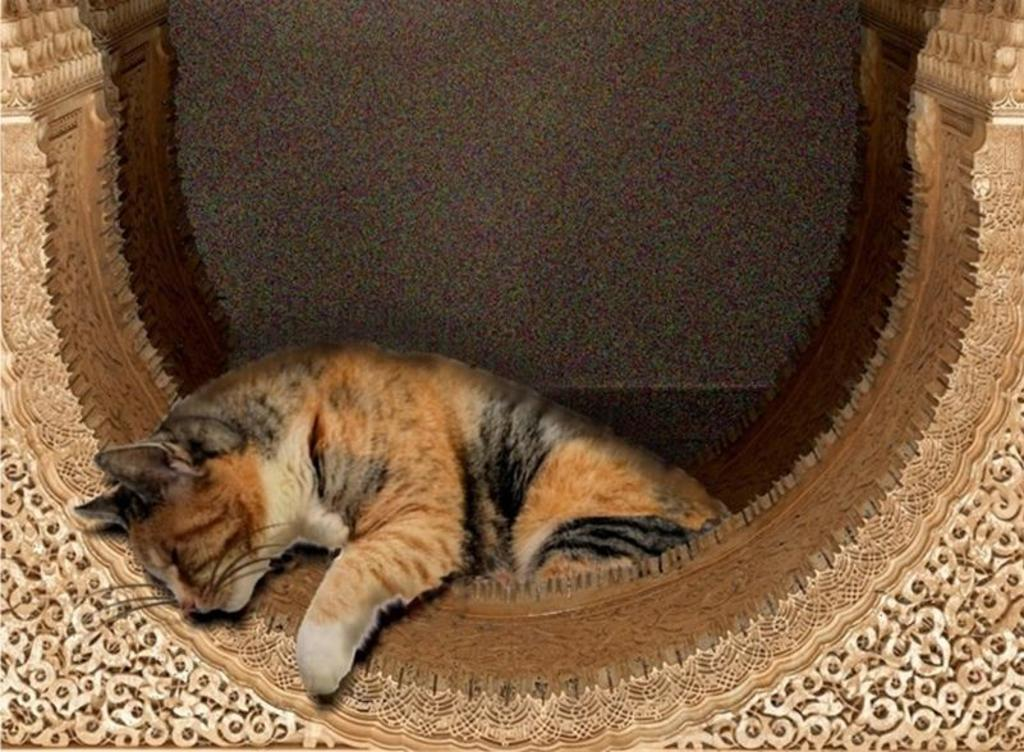What type of animal can be seen in the image? There is a cat in the image. What is the wooden object in the image like? The wooden object in the image has a design. How would you describe the background of the image? The background of the image is blurry. What can be seen in the distance in the image? There is a wall visible in the background of the image. How does the cat's tail contribute to the development of the wooden object in the image? The cat's tail does not contribute to the development of the wooden object in the image, as there is no indication that the cat's tail is interacting with the object. 